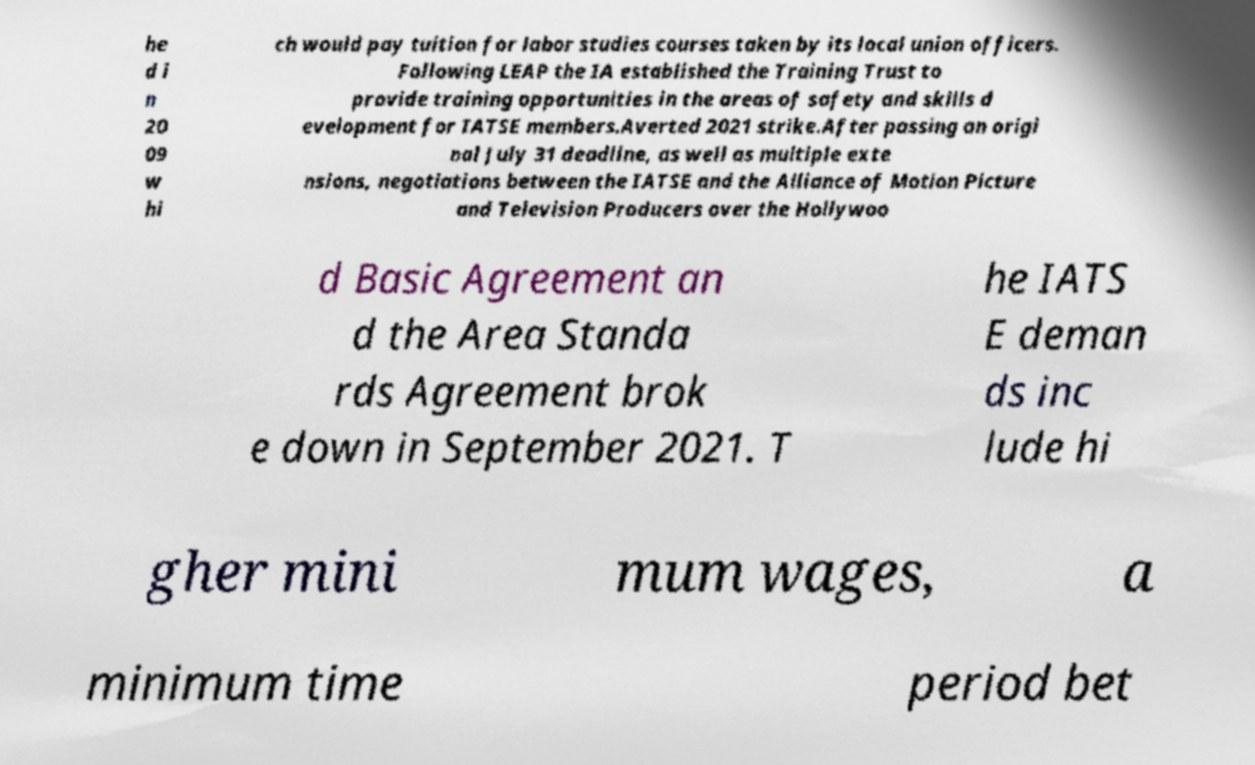I need the written content from this picture converted into text. Can you do that? he d i n 20 09 w hi ch would pay tuition for labor studies courses taken by its local union officers. Following LEAP the IA established the Training Trust to provide training opportunities in the areas of safety and skills d evelopment for IATSE members.Averted 2021 strike.After passing an origi nal July 31 deadline, as well as multiple exte nsions, negotiations between the IATSE and the Alliance of Motion Picture and Television Producers over the Hollywoo d Basic Agreement an d the Area Standa rds Agreement brok e down in September 2021. T he IATS E deman ds inc lude hi gher mini mum wages, a minimum time period bet 